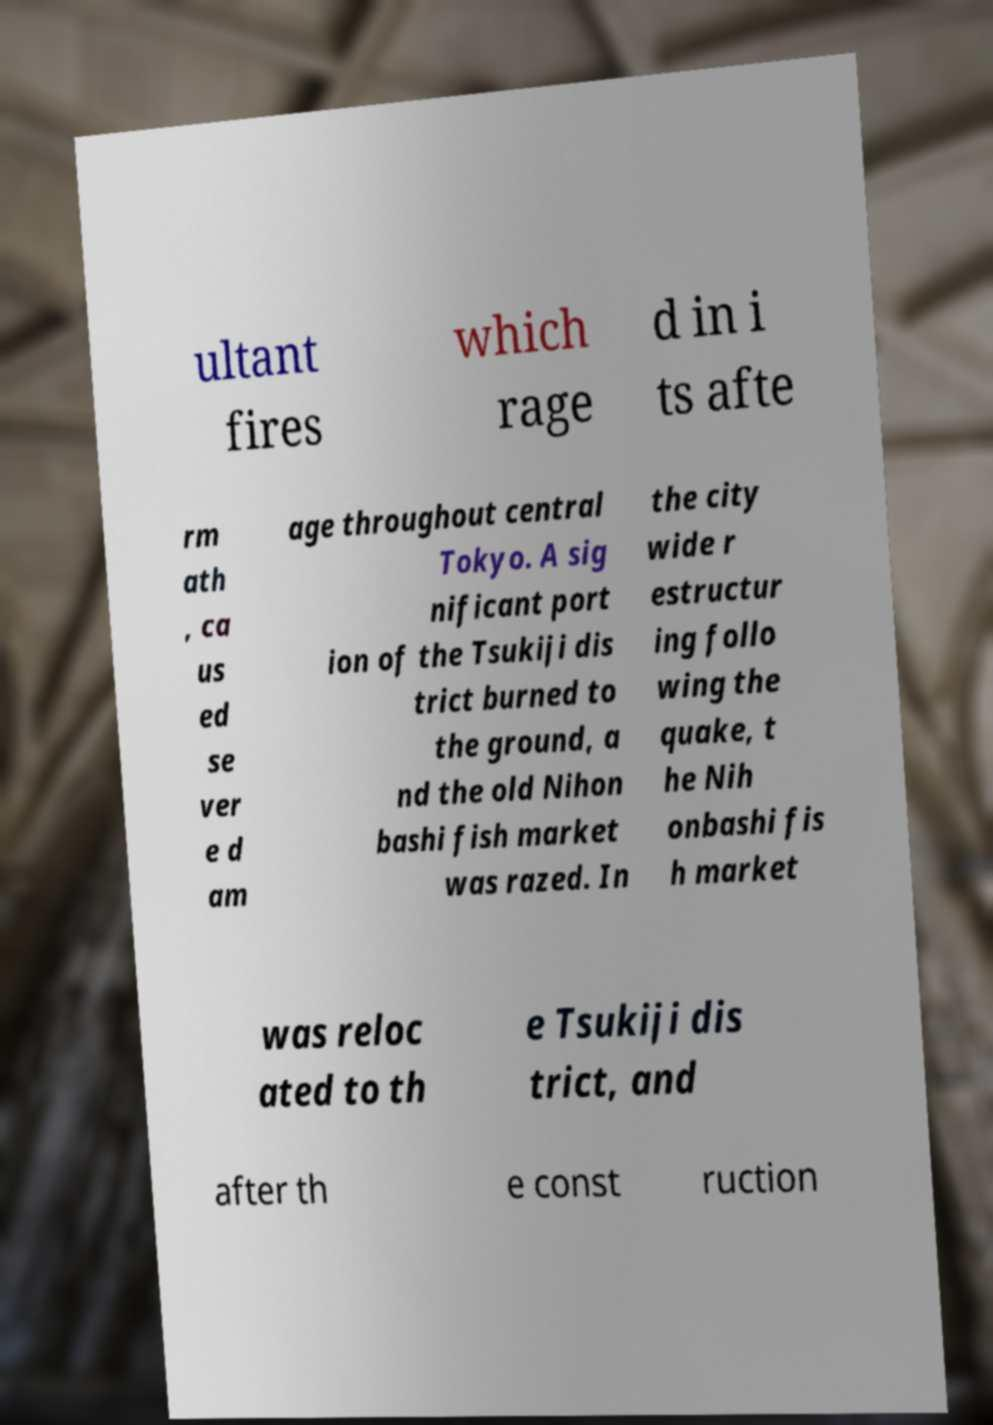There's text embedded in this image that I need extracted. Can you transcribe it verbatim? ultant fires which rage d in i ts afte rm ath , ca us ed se ver e d am age throughout central Tokyo. A sig nificant port ion of the Tsukiji dis trict burned to the ground, a nd the old Nihon bashi fish market was razed. In the city wide r estructur ing follo wing the quake, t he Nih onbashi fis h market was reloc ated to th e Tsukiji dis trict, and after th e const ruction 